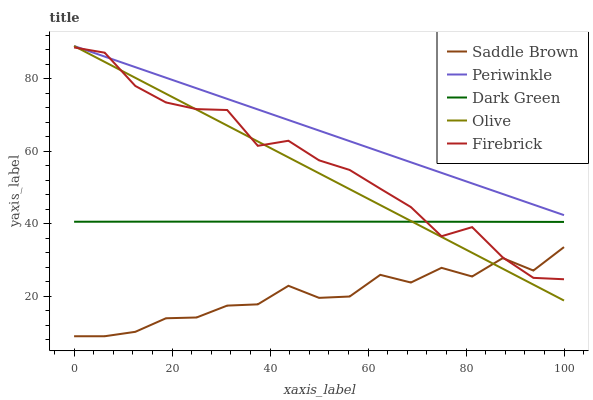Does Saddle Brown have the minimum area under the curve?
Answer yes or no. Yes. Does Periwinkle have the maximum area under the curve?
Answer yes or no. Yes. Does Firebrick have the minimum area under the curve?
Answer yes or no. No. Does Firebrick have the maximum area under the curve?
Answer yes or no. No. Is Olive the smoothest?
Answer yes or no. Yes. Is Saddle Brown the roughest?
Answer yes or no. Yes. Is Firebrick the smoothest?
Answer yes or no. No. Is Firebrick the roughest?
Answer yes or no. No. Does Saddle Brown have the lowest value?
Answer yes or no. Yes. Does Firebrick have the lowest value?
Answer yes or no. No. Does Periwinkle have the highest value?
Answer yes or no. Yes. Does Firebrick have the highest value?
Answer yes or no. No. Is Saddle Brown less than Periwinkle?
Answer yes or no. Yes. Is Periwinkle greater than Dark Green?
Answer yes or no. Yes. Does Olive intersect Dark Green?
Answer yes or no. Yes. Is Olive less than Dark Green?
Answer yes or no. No. Is Olive greater than Dark Green?
Answer yes or no. No. Does Saddle Brown intersect Periwinkle?
Answer yes or no. No. 